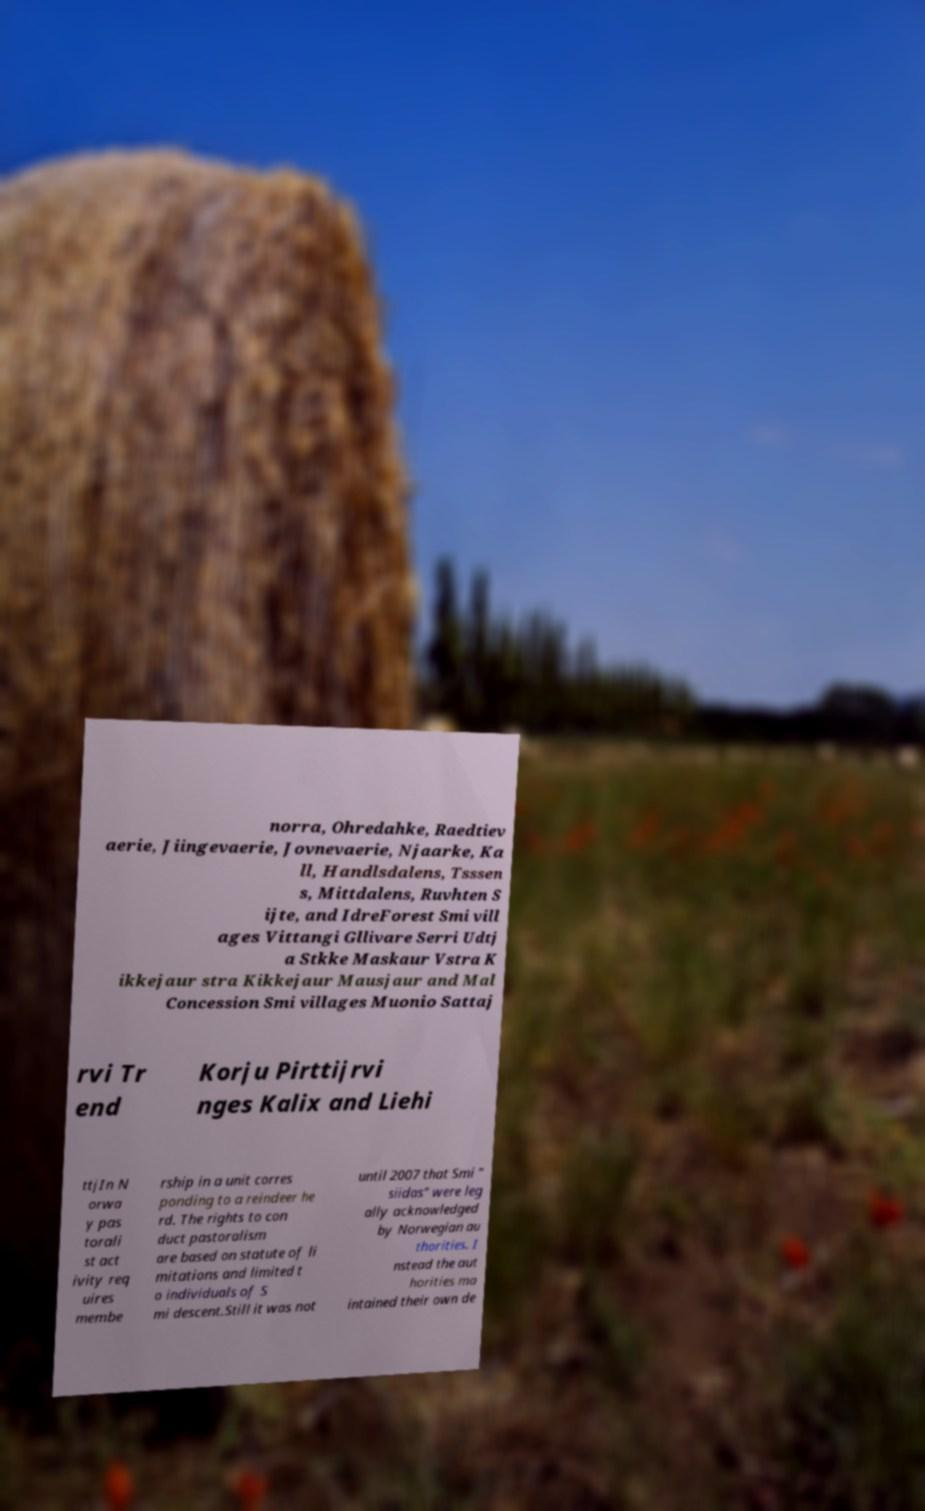For documentation purposes, I need the text within this image transcribed. Could you provide that? norra, Ohredahke, Raedtiev aerie, Jiingevaerie, Jovnevaerie, Njaarke, Ka ll, Handlsdalens, Tsssen s, Mittdalens, Ruvhten S ijte, and IdreForest Smi vill ages Vittangi Gllivare Serri Udtj a Stkke Maskaur Vstra K ikkejaur stra Kikkejaur Mausjaur and Mal Concession Smi villages Muonio Sattaj rvi Tr end Korju Pirttijrvi nges Kalix and Liehi ttjIn N orwa y pas torali st act ivity req uires membe rship in a unit corres ponding to a reindeer he rd. The rights to con duct pastoralism are based on statute of li mitations and limited t o individuals of S mi descent.Still it was not until 2007 that Smi " siidas" were leg ally acknowledged by Norwegian au thorities. I nstead the aut horities ma intained their own de 